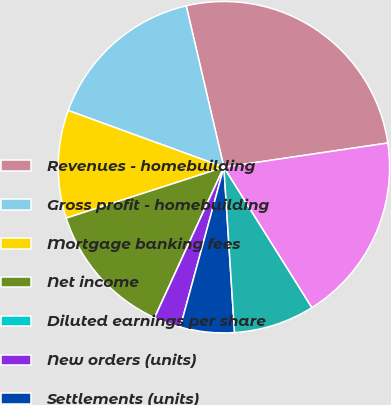Convert chart to OTSL. <chart><loc_0><loc_0><loc_500><loc_500><pie_chart><fcel>Revenues - homebuilding<fcel>Gross profit - homebuilding<fcel>Mortgage banking fees<fcel>Net income<fcel>Diluted earnings per share<fcel>New orders (units)<fcel>Settlements (units)<fcel>Backlog end of period (units)<fcel>Loans closed<nl><fcel>26.32%<fcel>15.79%<fcel>10.53%<fcel>13.16%<fcel>0.0%<fcel>2.63%<fcel>5.26%<fcel>7.89%<fcel>18.42%<nl></chart> 